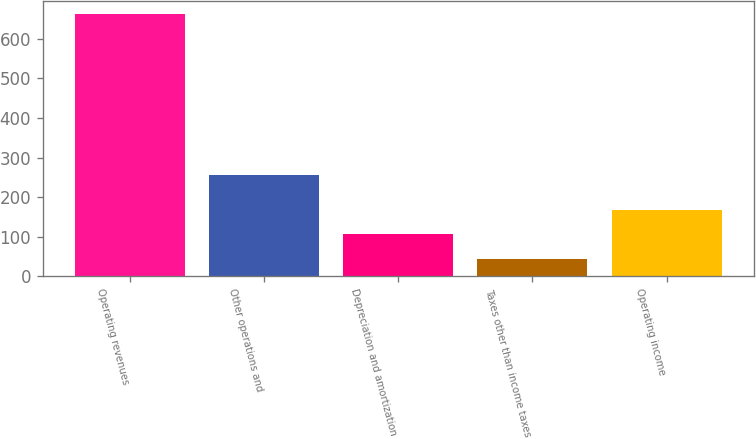Convert chart. <chart><loc_0><loc_0><loc_500><loc_500><bar_chart><fcel>Operating revenues<fcel>Other operations and<fcel>Depreciation and amortization<fcel>Taxes other than income taxes<fcel>Operating income<nl><fcel>663<fcel>256<fcel>105.9<fcel>44<fcel>167.8<nl></chart> 